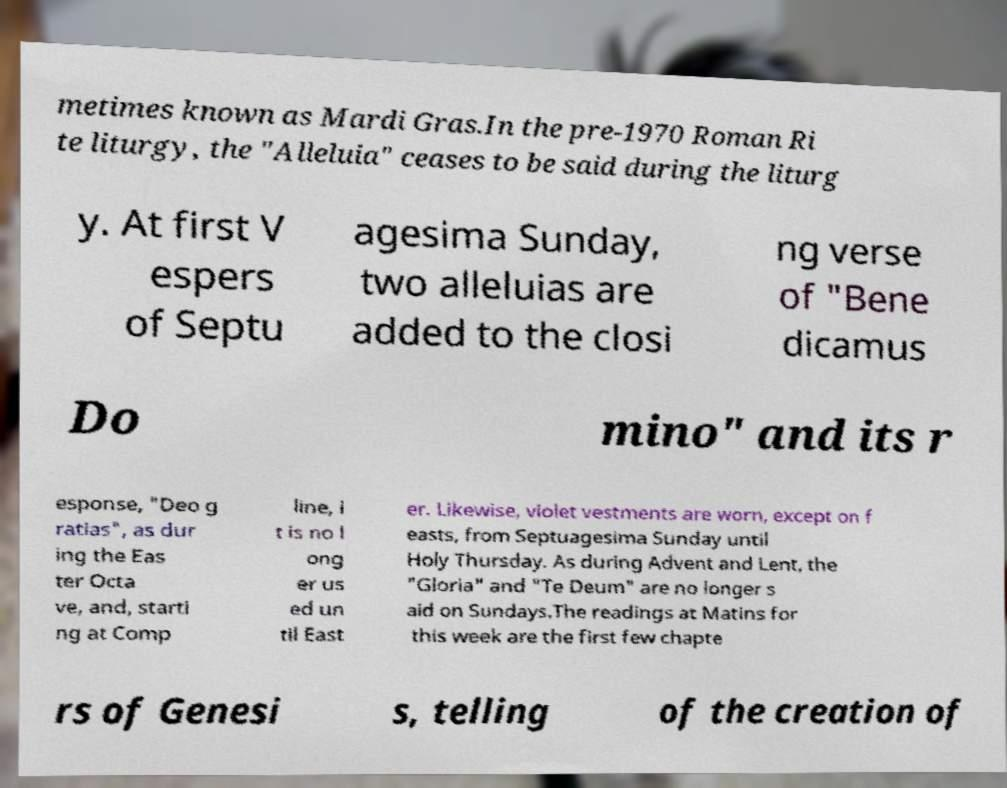Please read and relay the text visible in this image. What does it say? metimes known as Mardi Gras.In the pre-1970 Roman Ri te liturgy, the "Alleluia" ceases to be said during the liturg y. At first V espers of Septu agesima Sunday, two alleluias are added to the closi ng verse of "Bene dicamus Do mino" and its r esponse, "Deo g ratias", as dur ing the Eas ter Octa ve, and, starti ng at Comp line, i t is no l ong er us ed un til East er. Likewise, violet vestments are worn, except on f easts, from Septuagesima Sunday until Holy Thursday. As during Advent and Lent, the "Gloria" and "Te Deum" are no longer s aid on Sundays.The readings at Matins for this week are the first few chapte rs of Genesi s, telling of the creation of 